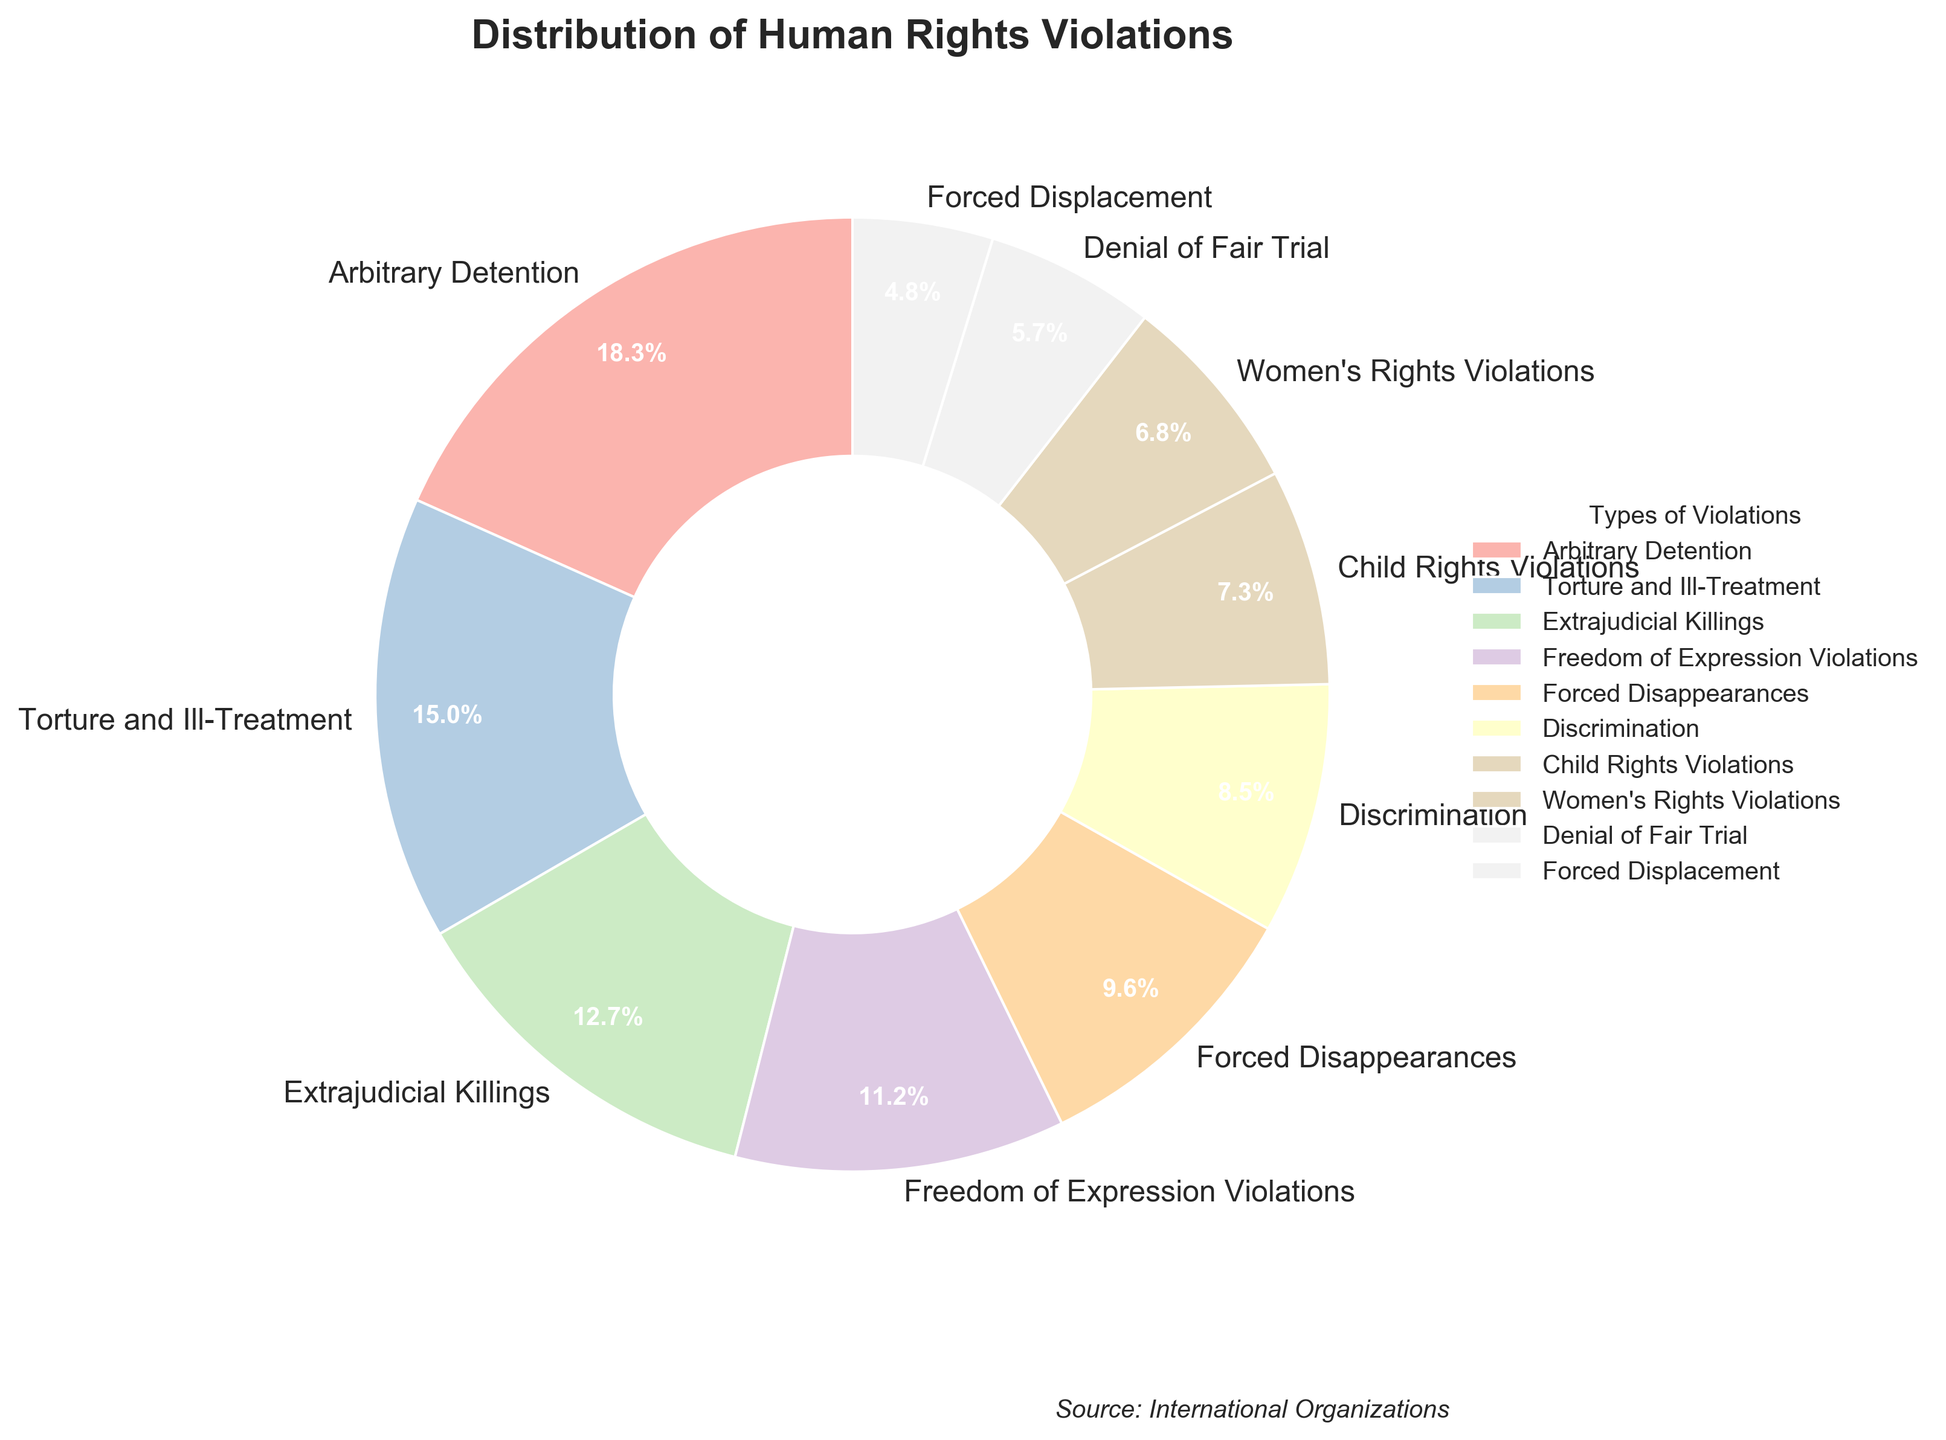What type of violation has the highest percentage? By visually inspecting the pie chart, we can see that the largest segment belongs to "Arbitrary Detention". This indicates it has the highest percentage.
Answer: Arbitrary Detention Which two types of violations have a combined percentage closest to 20%? We need to sum up the percentages and find the closest to 20%. By inspection, the combined percentage of "Denial of Fair Trial" (5.8%) and "Forced Disappearances" (9.7%) is 15.5%. Adding the "Forced Displacement" (4.8%) makes it 20.3%, which is the closest to 20%.
Answer: Denial of Fair Trial and Forced Displacement How much larger is the percentage of Arbitrary Detention compared to Torture and Ill-Treatment? Find the difference between the percentages of these two types. Arbitrary Detention is 18.5% and Torture and Ill-Treatment is 15.2%, so the difference is 18.5 - 15.2 = 3.3.
Answer: 3.3% What is the combined percentage of Child Rights Violations and Women's Rights Violations? Adding their individual percentages: 7.4% (Child Rights Violations) + 6.9% (Women's Rights Violations) = 14.3%.
Answer: 14.3% Which type of violation has a smaller percentage, Forced Disappearances or Freedom of Expression Violations? Compare the percentages of both types. Forced Disappearances is 9.7% and Freedom of Expression Violations is 11.3%. Since 9.7% is less than 11.3%, Forced Disappearances is smaller.
Answer: Forced Disappearances What is the average percentage of the top three types of violations? Sum the percentages of the top three types and divide by three. Top three are Arbitrary Detention (18.5%), Torture and Ill-Treatment (15.2%), and Extrajudicial Killings (12.8%). The sum is 18.5 + 15.2 + 12.8 = 46.5, and the average is 46.5 / 3 = 15.5%.
Answer: 15.5% What percentage difference is there between the highest and lowest reported types of violations? Find the highest and lowest percentages, then calculate the difference. The highest is Arbitrary Detention at 18.5% and the lowest is Forced Displacement at 4.8%. Difference is 18.5 - 4.8 = 13.7%.
Answer: 13.7% Which types of violations are represented with visually larger segments than Women's Rights Violations? Checking the pie chart, the segments for Arbitrary Detention, Torture and Ill-Treatment, Extrajudicial Killings, Freedom of Expression Violations, Forced Disappearances, Discrimination, and Child Rights Violations are visually larger.
Answer: Arbitrary Detention, Torture and Ill-Treatment, Extrajudicial Killings, Freedom of Expression Violations, Forced Disappearances, Discrimination, Child Rights Violations 